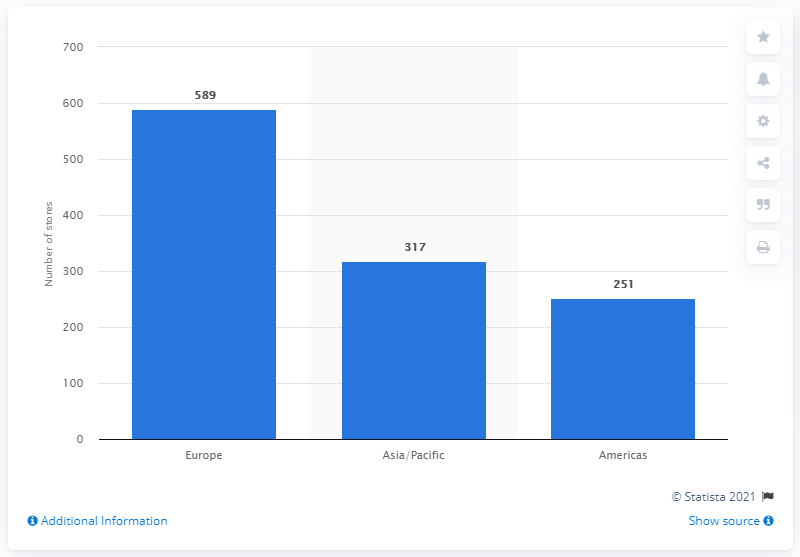Give some essential details in this illustration. The Hugo Boss Group operated 589 stores in Europe in 2020. 